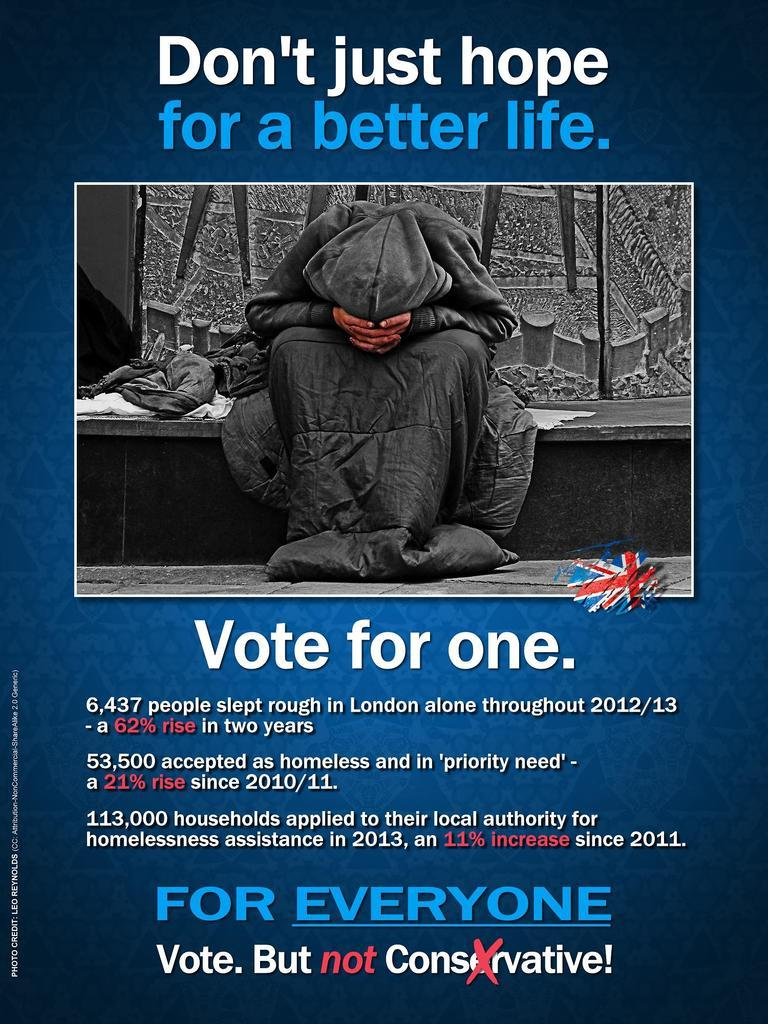What type of visual is the image? The image is a poster. What can be found on the poster besides visual elements? There is text and numbers on the poster. Can you describe the person depicted on the poster? There is a person depicted on the poster, but their specific features or actions are not mentioned in the facts. What else is present on the poster that hasn't been mentioned yet? There are a few unspecified things on the poster. Are there any cobwebs visible on the person depicted in the poster? There is no mention of cobwebs in the provided facts, so we cannot determine if any are present on the person depicted in the poster. What type of potatoes are shown in the image? There is no mention of potatoes in the provided facts, so we cannot determine if any are present in the image. 